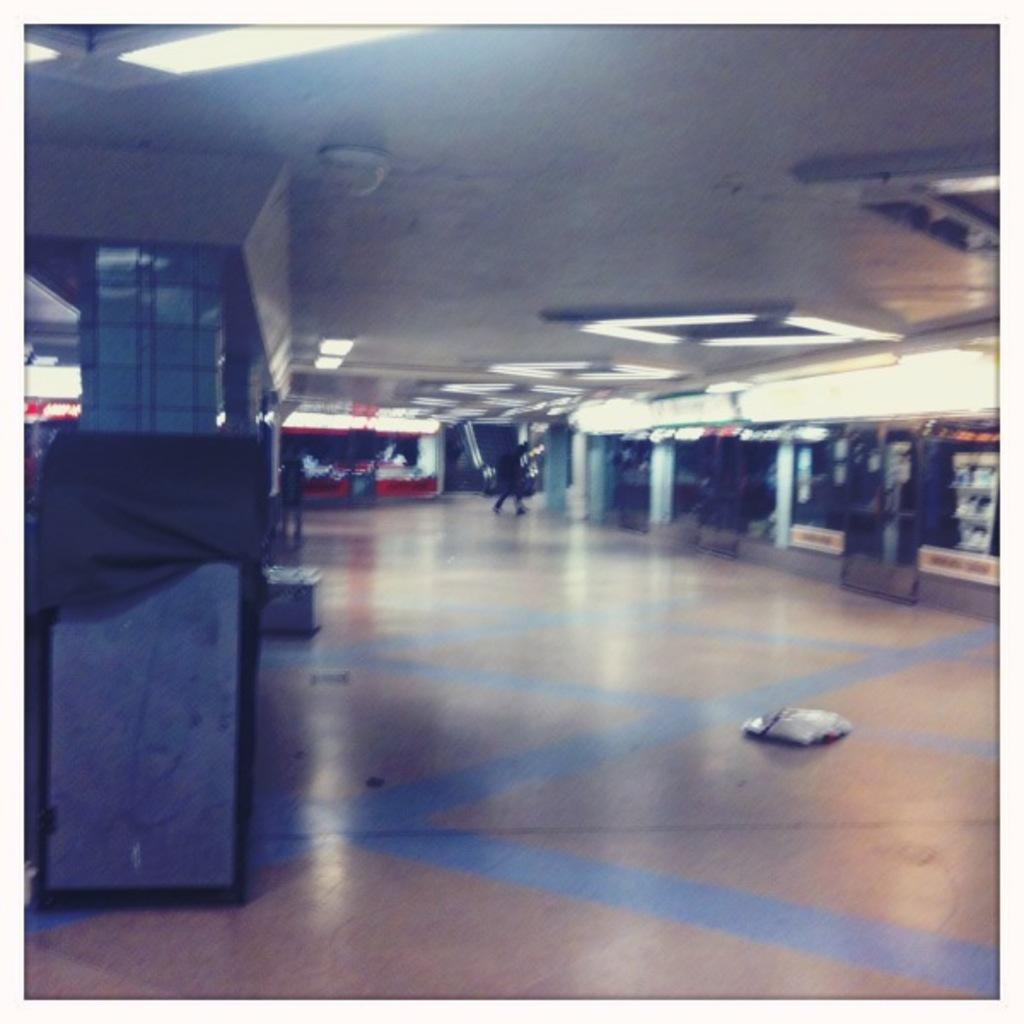What type of lighting is present in the image? There are lights on the ceiling in the image. Can you describe the person visible in the background of the image? There is a person visible in the background of the image, but no specific details are provided. What is the object on the ground in the image? The fact does not specify the object on the ground, so we cannot provide a definitive answer. What type of cat can be seen playing with thunder in the image? There is no cat or thunder present in the image. Is the person in the image wearing a wristwatch? The fact does not mention a wristwatch or any other accessories worn by the person in the image, so we cannot provide a definitive answer. 